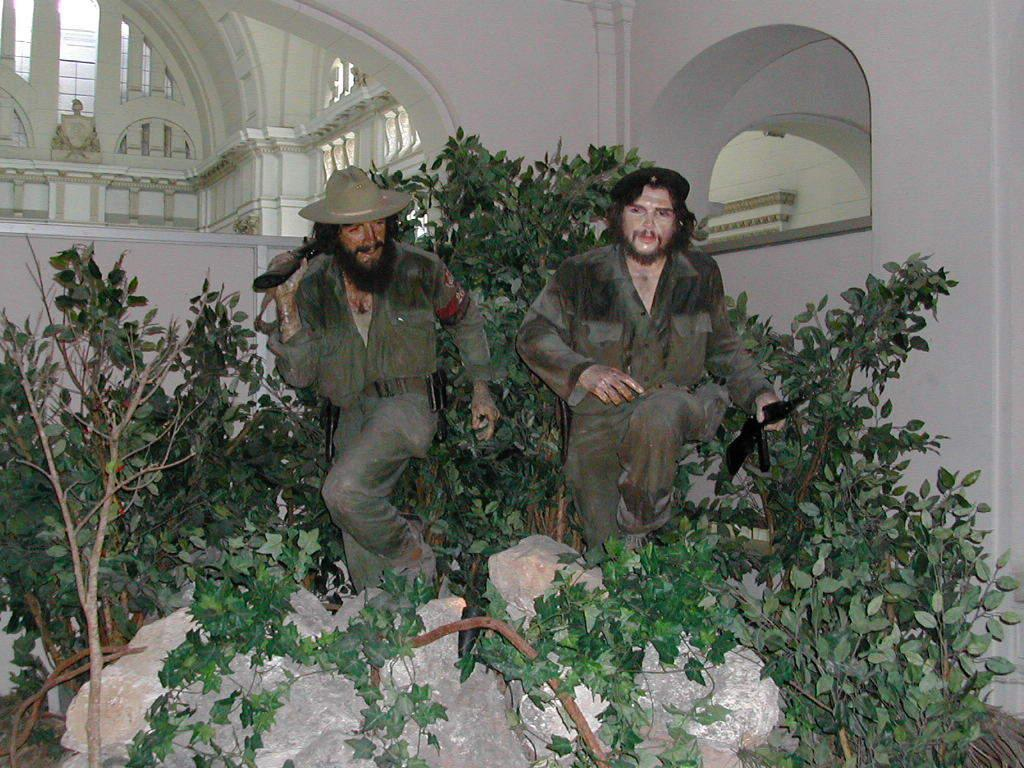What can be seen in front of the wall in the image? There are statues in front of the wall. What is located in the middle of the image? There are plants in the middle of the image. What is at the bottom of the image? There are rocks at the bottom of the image. Can you see a duck kissing a ghost in the image? There is no duck or ghost present in the image. 